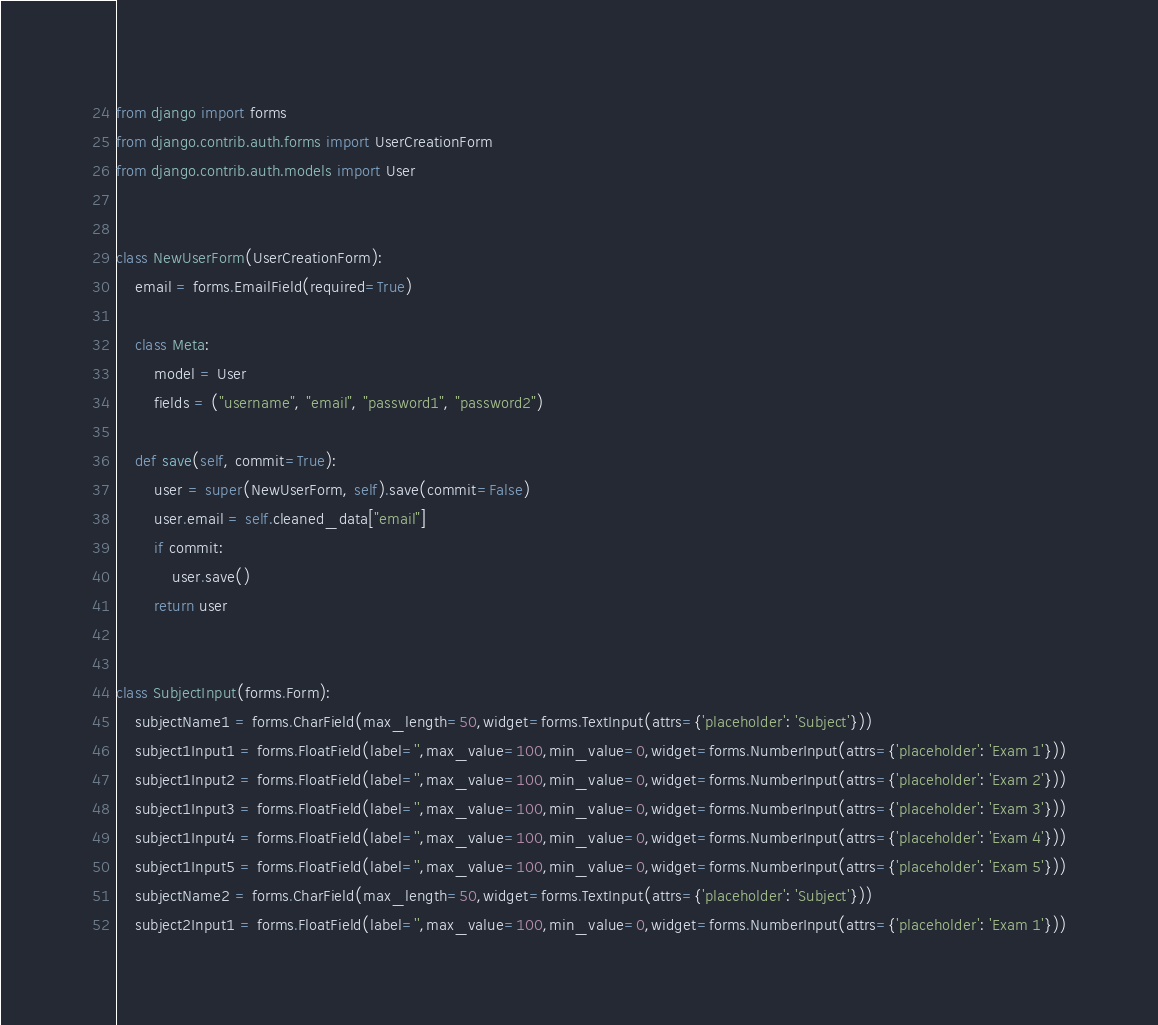<code> <loc_0><loc_0><loc_500><loc_500><_Python_>from django import forms
from django.contrib.auth.forms import UserCreationForm
from django.contrib.auth.models import User


class NewUserForm(UserCreationForm):
    email = forms.EmailField(required=True)

    class Meta:
        model = User
        fields = ("username", "email", "password1", "password2")

    def save(self, commit=True):
        user = super(NewUserForm, self).save(commit=False)
        user.email = self.cleaned_data["email"]
        if commit:
            user.save()
        return user


class SubjectInput(forms.Form):
    subjectName1 = forms.CharField(max_length=50,widget=forms.TextInput(attrs={'placeholder': 'Subject'}))
    subject1Input1 = forms.FloatField(label='',max_value=100,min_value=0,widget=forms.NumberInput(attrs={'placeholder': 'Exam 1'}))
    subject1Input2 = forms.FloatField(label='',max_value=100,min_value=0,widget=forms.NumberInput(attrs={'placeholder': 'Exam 2'}))
    subject1Input3 = forms.FloatField(label='',max_value=100,min_value=0,widget=forms.NumberInput(attrs={'placeholder': 'Exam 3'}))
    subject1Input4 = forms.FloatField(label='',max_value=100,min_value=0,widget=forms.NumberInput(attrs={'placeholder': 'Exam 4'}))
    subject1Input5 = forms.FloatField(label='',max_value=100,min_value=0,widget=forms.NumberInput(attrs={'placeholder': 'Exam 5'}))
    subjectName2 = forms.CharField(max_length=50,widget=forms.TextInput(attrs={'placeholder': 'Subject'}))
    subject2Input1 = forms.FloatField(label='',max_value=100,min_value=0,widget=forms.NumberInput(attrs={'placeholder': 'Exam 1'}))</code> 